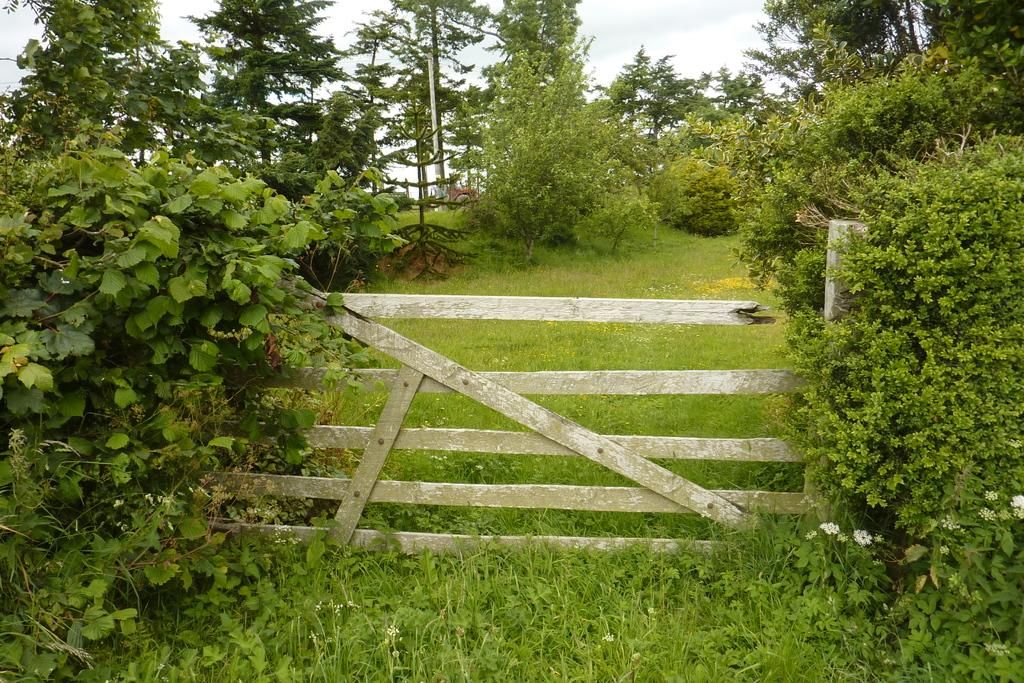What type of material is used for the fencing in the image? The fencing in the image is made of wood. Where is the wooden fencing located in relation to the grass? The wooden fencing is on the surface of the grass. What can be seen in the background of the image? There are trees and the sky visible in the background of the image. What type of sign is hanging from the wooden fencing in the image? There is no sign hanging from the wooden fencing in the image. 